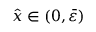<formula> <loc_0><loc_0><loc_500><loc_500>\hat { x } \in ( 0 , \bar { \varepsilon } )</formula> 